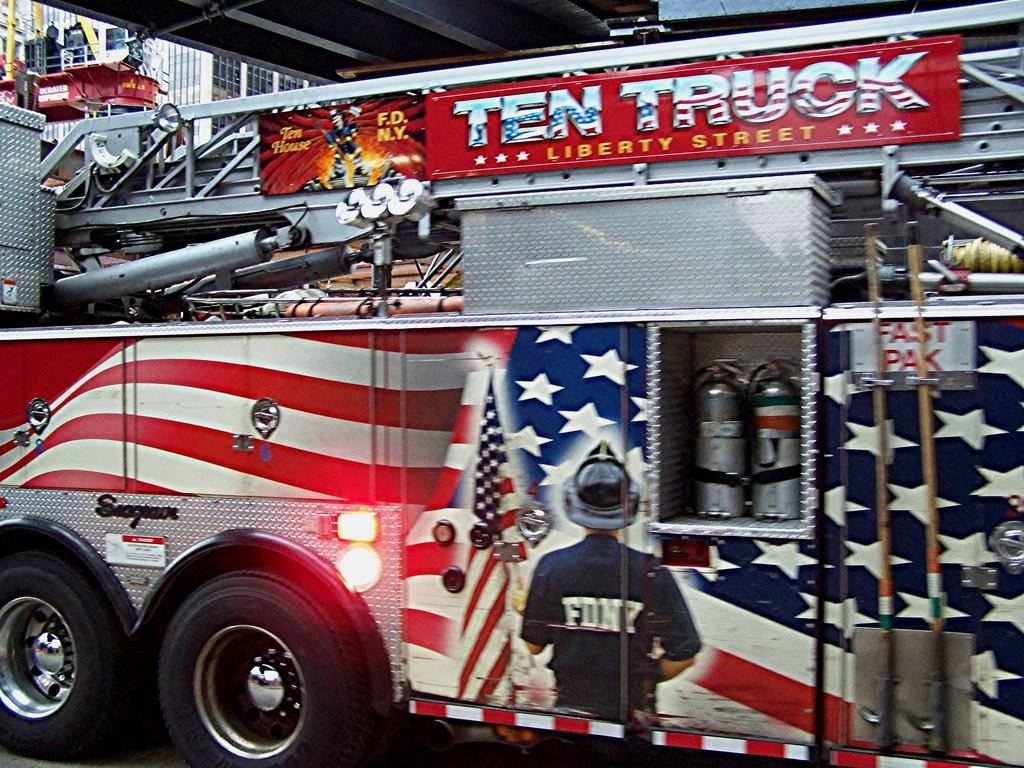What is the main subject of the image? The main subject of the image is a truck. What color is the truck? The truck is red in color. Are there any additional features on the truck? Yes, there are paintings on the truck. What type of button can be seen on the truck's dashboard in the image? There is no button visible on the truck's dashboard in the image. What authority figure is depicted in the paintings on the truck? The provided facts do not mention any authority figures depicted in the paintings on the truck. 